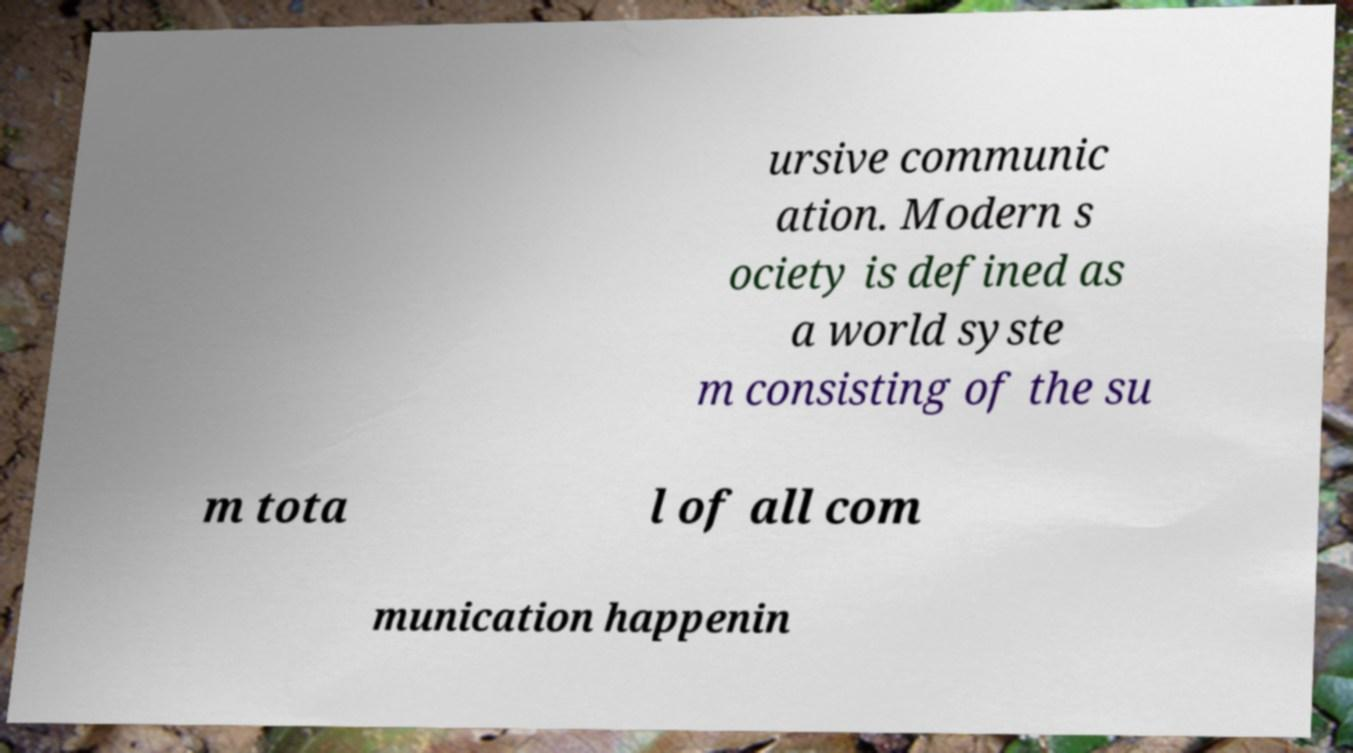Please read and relay the text visible in this image. What does it say? ursive communic ation. Modern s ociety is defined as a world syste m consisting of the su m tota l of all com munication happenin 